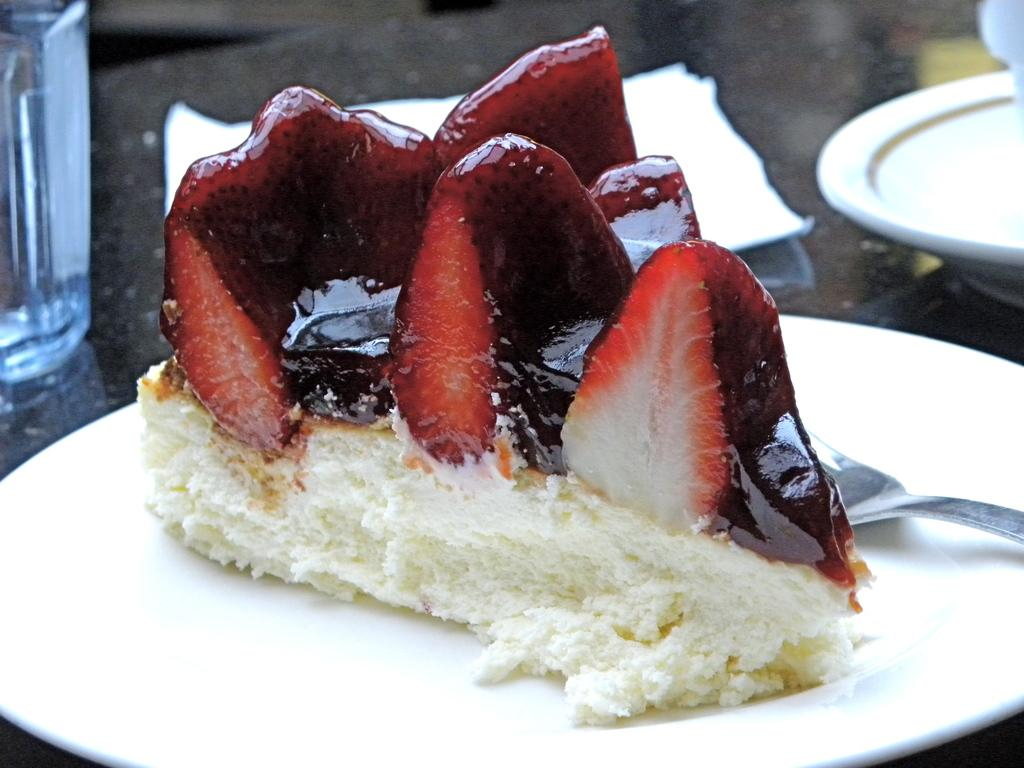What objects can be seen in the image related to serving or eating food? There are plates, a spoon, and a napkin visible in the image. What is on one of the plates in the image? There is food on one of the plates in the image. What can be seen in the background of the image? There is a bottle and a napkin present in the background of the image. What is the color of the food on the plate? The color of the food is maroon and white. Can you see any whips being used to prepare the food in the image? There are no whips visible in the image, nor is there any indication of food preparation taking place. Are there any cherries on the plate with the maroon and white food? The image does not show any cherries on the plate with the maroon and white food. 